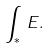Convert formula to latex. <formula><loc_0><loc_0><loc_500><loc_500>\int _ { \ast } \, E .</formula> 